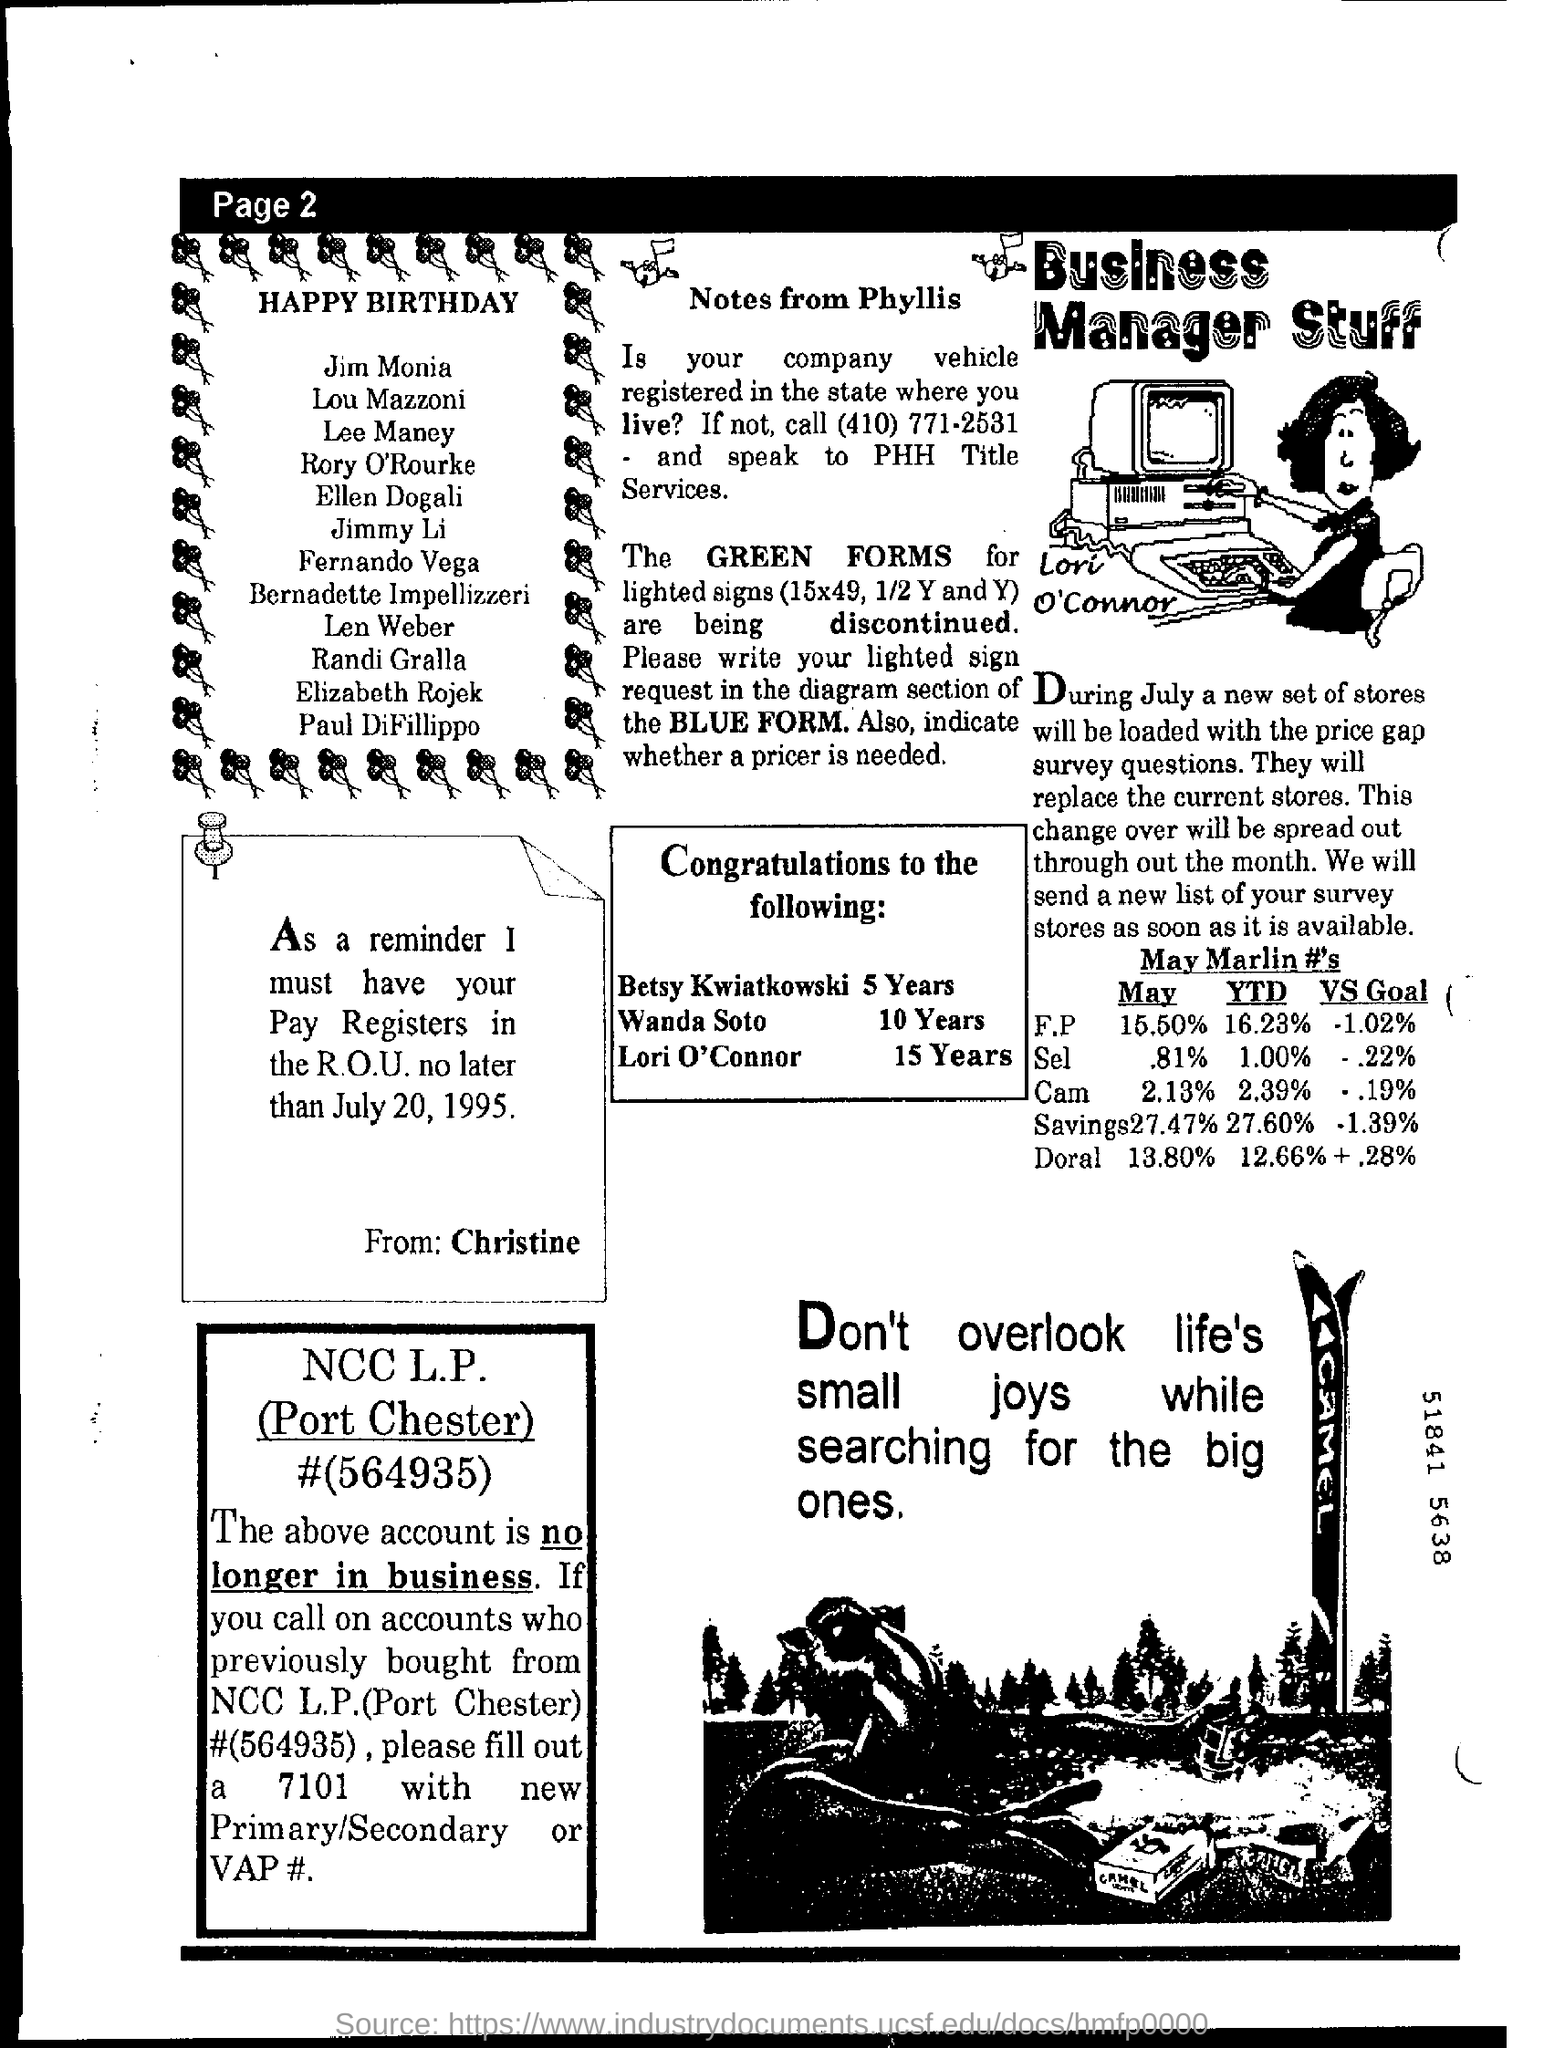When should Christine have your Pay registers in the R.OU.?
Keep it short and to the point. No later than july 20, 1995. 